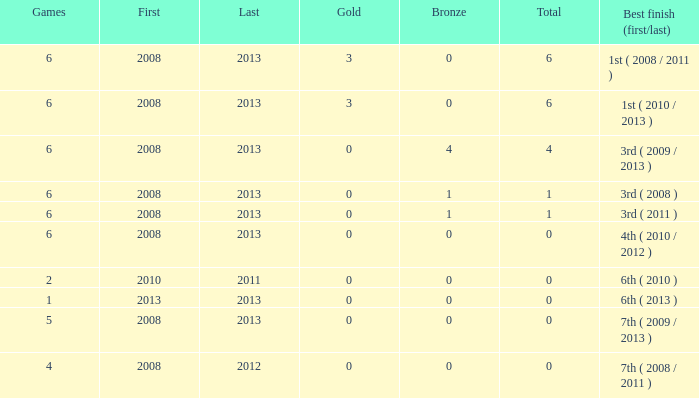What is the latest first year with 0 total medals and over 0 golds? 2008.0. 